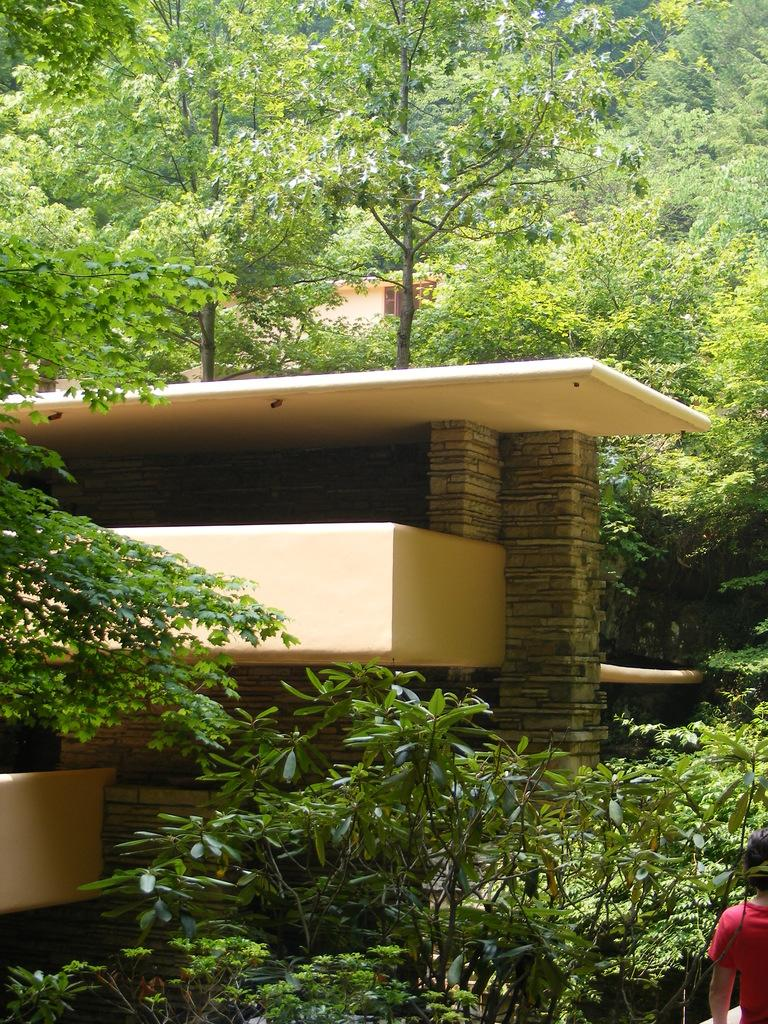What can be seen in the background of the image? There are trees in the background of the image. What type of structure is present in the image? There is a building in the image. Can you describe the person in the image? There is a person at the right bottom of the image. How many balls are hanging from the branches of the trees in the image? There are no balls hanging from the branches of the trees in the image; only trees are present. What type of suit is the person wearing in the image? There is no suit visible in the image; the person is not wearing any clothing mentioned in the provided facts. 